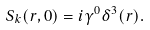<formula> <loc_0><loc_0><loc_500><loc_500>S _ { k } ( r , 0 ) = i \gamma ^ { 0 } \delta ^ { 3 } ( r ) .</formula> 